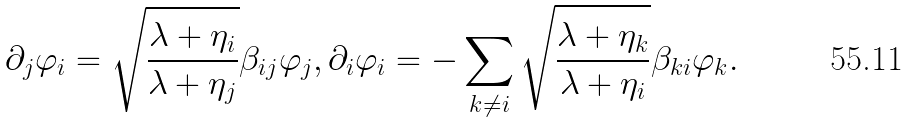Convert formula to latex. <formula><loc_0><loc_0><loc_500><loc_500>\partial _ { j } \varphi _ { i } = \sqrt { \frac { \lambda + \eta _ { i } } { \lambda + \eta _ { j } } } \beta _ { i j } \varphi _ { j } , \partial _ { i } \varphi _ { i } = - \sum _ { k \ne i } \sqrt { \frac { \lambda + \eta _ { k } } { \lambda + \eta _ { i } } } \beta _ { k i } \varphi _ { k } .</formula> 